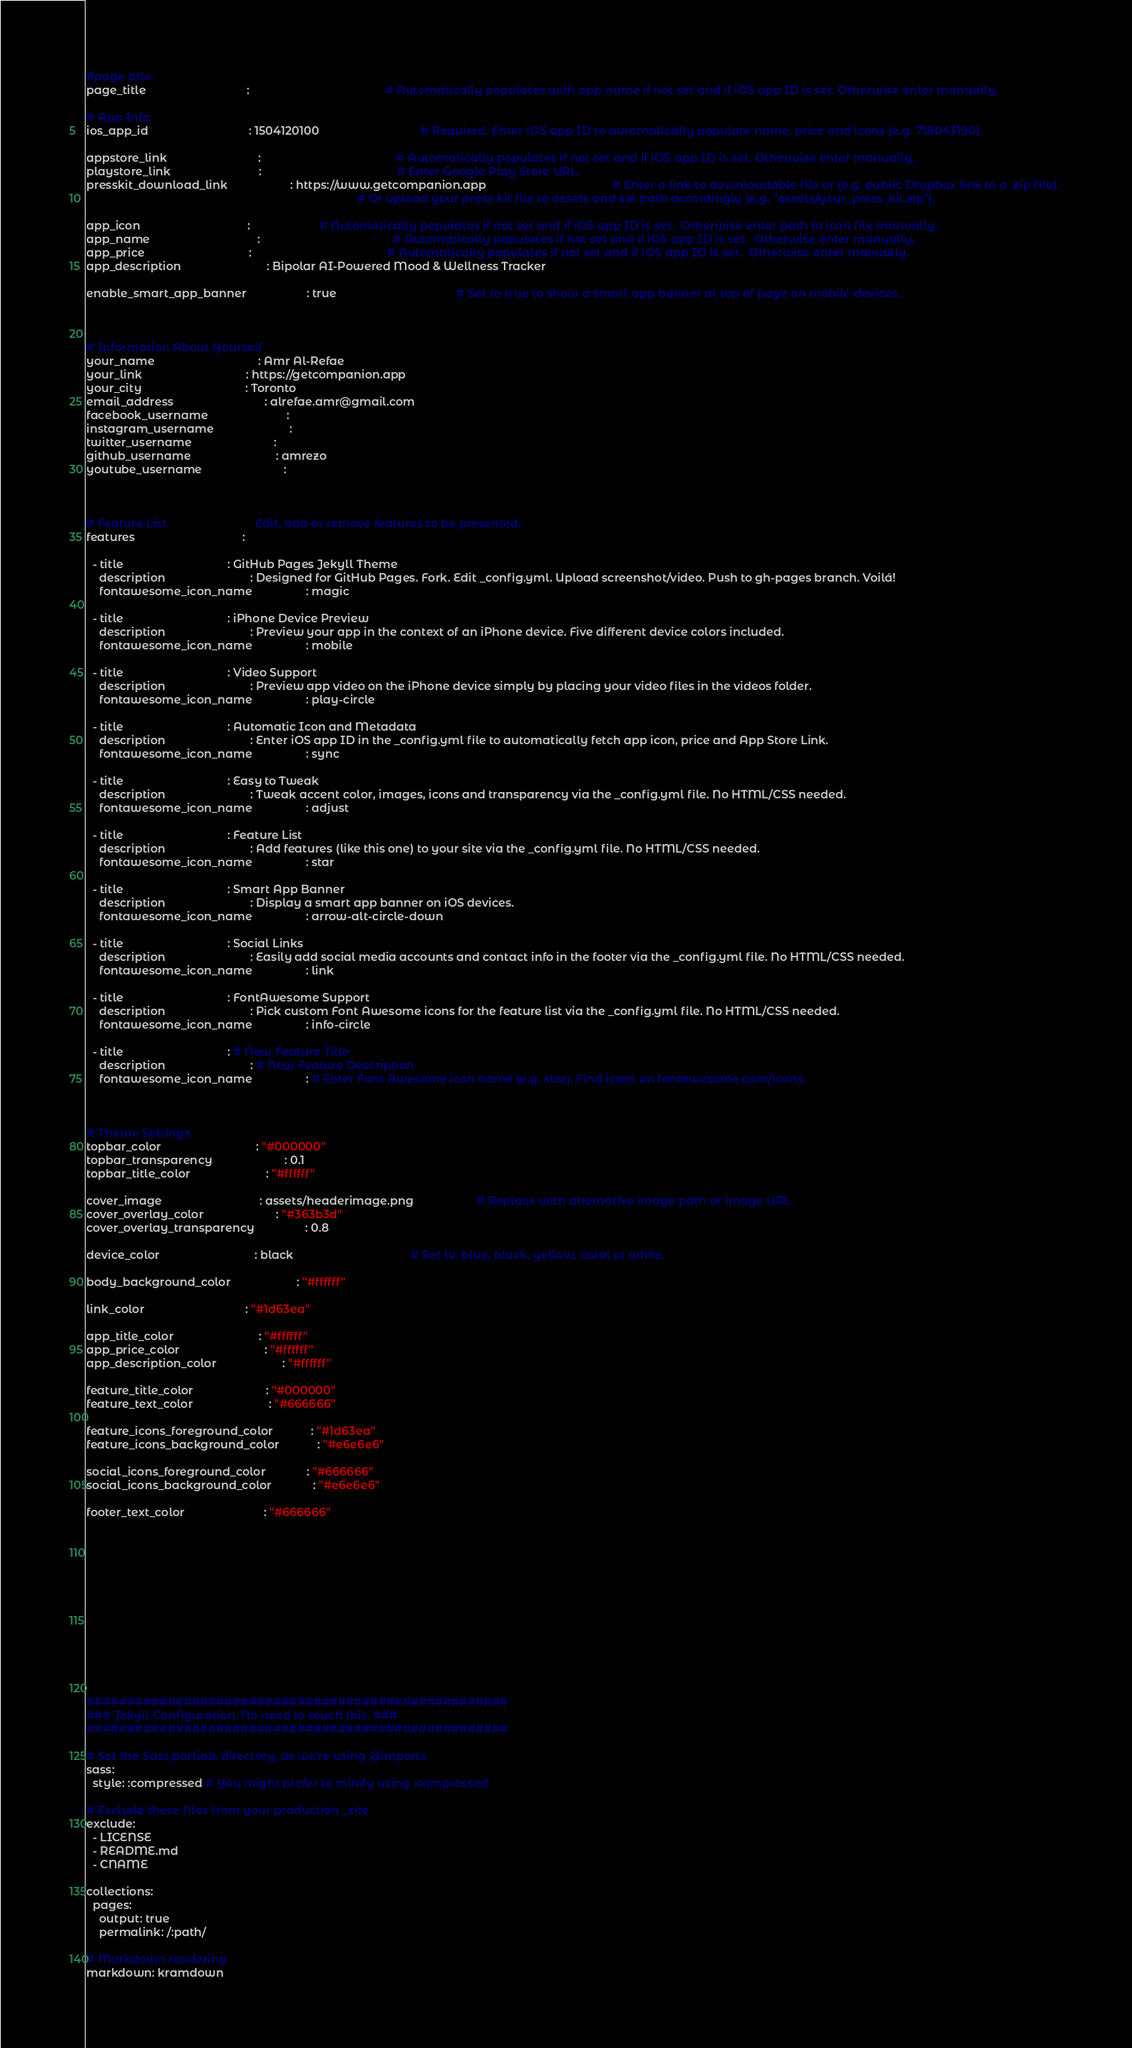<code> <loc_0><loc_0><loc_500><loc_500><_YAML_>#page title
page_title                                :                                           # Automatically populates with app name if not set and if iOS app ID is set. Otherwise enter manually.

# App Info
ios_app_id                                : 1504120100                                # Required. Enter iOS app ID to automatically populate name, price and icons (e.g. 718043190).

appstore_link                             :                                           # Automatically populates if not set and if iOS app ID is set. Otherwise enter manually.
playstore_link                            :                                           # Enter Google Play Store URL.
presskit_download_link                    : https://www.getcompanion.app                                        # Enter a link to downloadable file or (e.g. public Dropbox link to a .zip file). 
                                                                                      # Or upload your press kit file to assets and set path accordingly (e.g. "assets/your_press_kit.zip").

app_icon                                  :                      # Automatically populates if not set and if iOS app ID is set.  Otherwise enter path to icon file manually.
app_name                                  :                                          # Automatically populates if not set and if iOS app ID is set.  Otherwise enter manually.
app_price                                 :                                           # Automatically populates if not set and if iOS app ID is set.  Otherwise enter manually.
app_description                           : Bipolar AI-Powered Mood & Wellness Tracker

enable_smart_app_banner                   : true                                      # Set to true to show a smart app banner at top of page on mobile devices.



# Information About Yourself
your_name                                 : Amr Al-Refae                               
your_link                                 : https://getcompanion.app                     
your_city                                 : Toronto                               
email_address                             : alrefae.amr@gmail.com
facebook_username                         :                                           
instagram_username                        : 
twitter_username                          : 
github_username                           : amrezo
youtube_username                          :



# Feature List                            Edit, add or remove features to be presented.
features                                  :

  - title                                 : GitHub Pages Jekyll Theme
    description                           : Designed for GitHub Pages. Fork. Edit _config.yml. Upload screenshot/video. Push to gh-pages branch. Voilá!
    fontawesome_icon_name                 : magic
    
  - title                                 : iPhone Device Preview
    description                           : Preview your app in the context of an iPhone device. Five different device colors included.
    fontawesome_icon_name                 : mobile

  - title                                 : Video Support
    description                           : Preview app video on the iPhone device simply by placing your video files in the videos folder.
    fontawesome_icon_name                 : play-circle

  - title                                 : Automatic Icon and Metadata
    description                           : Enter iOS app ID in the _config.yml file to automatically fetch app icon, price and App Store Link.
    fontawesome_icon_name                 : sync

  - title                                 : Easy to Tweak
    description                           : Tweak accent color, images, icons and transparency via the _config.yml file. No HTML/CSS needed.
    fontawesome_icon_name                 : adjust
  
  - title                                 : Feature List
    description                           : Add features (like this one) to your site via the _config.yml file. No HTML/CSS needed.
    fontawesome_icon_name                 : star

  - title                                 : Smart App Banner
    description                           : Display a smart app banner on iOS devices.
    fontawesome_icon_name                 : arrow-alt-circle-down

  - title                                 : Social Links
    description                           : Easily add social media accounts and contact info in the footer via the _config.yml file. No HTML/CSS needed.
    fontawesome_icon_name                 : link

  - title                                 : FontAwesome Support
    description                           : Pick custom Font Awesome icons for the feature list via the _config.yml file. No HTML/CSS needed.
    fontawesome_icon_name                 : info-circle

  - title                                 : # New Feature Title
    description                           : # New Feature Description
    fontawesome_icon_name                 : # Enter Font Awesome icon name (e.g. star). Find icons on fontawesome.com/icons.



# Theme Settings
topbar_color                              : "#000000"
topbar_transparency                       : 0.1
topbar_title_color                        : "#ffffff"

cover_image                               : assets/headerimage.png                    # Replace with alternative image path or image URL.
cover_overlay_color                       : "#363b3d"
cover_overlay_transparency                : 0.8

device_color                              : black                                     # Set to: blue, black, yellow, coral or white.

body_background_color                     : "#ffffff"

link_color                                : "#1d63ea"

app_title_color                           : "#ffffff"
app_price_color                           : "#ffffff"
app_description_color                     : "#ffffff"

feature_title_color                       : "#000000"
feature_text_color                        : "#666666"

feature_icons_foreground_color            : "#1d63ea"
feature_icons_background_color            : "#e6e6e6"

social_icons_foreground_color             : "#666666"
social_icons_background_color             : "#e6e6e6"

footer_text_color                         : "#666666"













####################################################
### Jekyll Configuration. No need to touch this. ###
####################################################

# Set the Sass partials directory, as we're using @imports
sass:
  style: :compressed # You might prefer to minify using :compressed

# Exclude these files from your production _site
exclude:
  - LICENSE
  - README.md
  - CNAME

collections:
  pages:
    output: true
    permalink: /:path/

# Markdown rendering
markdown: kramdown
</code> 